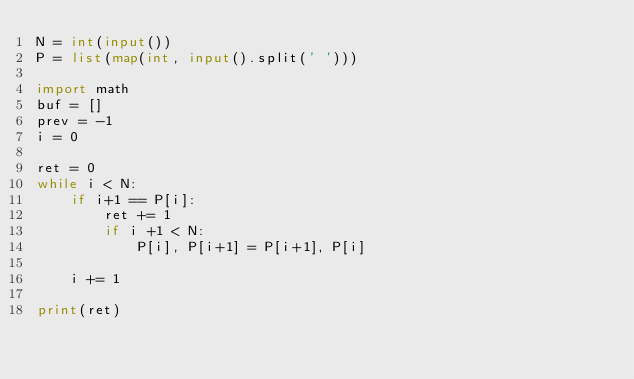<code> <loc_0><loc_0><loc_500><loc_500><_Python_>N = int(input())
P = list(map(int, input().split(' ')))

import math
buf = []
prev = -1
i = 0

ret = 0
while i < N:
    if i+1 == P[i]:
        ret += 1
        if i +1 < N:
            P[i], P[i+1] = P[i+1], P[i]

    i += 1

print(ret)</code> 